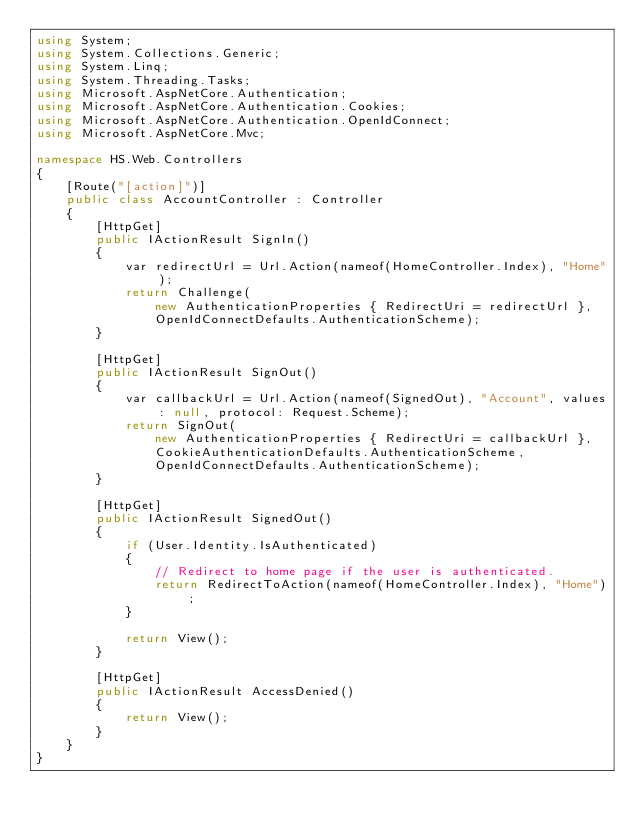Convert code to text. <code><loc_0><loc_0><loc_500><loc_500><_C#_>using System;
using System.Collections.Generic;
using System.Linq;
using System.Threading.Tasks;
using Microsoft.AspNetCore.Authentication;
using Microsoft.AspNetCore.Authentication.Cookies;
using Microsoft.AspNetCore.Authentication.OpenIdConnect;
using Microsoft.AspNetCore.Mvc;

namespace HS.Web.Controllers
{
    [Route("[action]")]
    public class AccountController : Controller
    {
        [HttpGet]
        public IActionResult SignIn()
        {
            var redirectUrl = Url.Action(nameof(HomeController.Index), "Home");
            return Challenge(
                new AuthenticationProperties { RedirectUri = redirectUrl },
                OpenIdConnectDefaults.AuthenticationScheme);
        }

        [HttpGet]
        public IActionResult SignOut()
        {
            var callbackUrl = Url.Action(nameof(SignedOut), "Account", values: null, protocol: Request.Scheme);
            return SignOut(
                new AuthenticationProperties { RedirectUri = callbackUrl },
                CookieAuthenticationDefaults.AuthenticationScheme,
                OpenIdConnectDefaults.AuthenticationScheme);
        }

        [HttpGet]
        public IActionResult SignedOut()
        {
            if (User.Identity.IsAuthenticated)
            {
                // Redirect to home page if the user is authenticated.
                return RedirectToAction(nameof(HomeController.Index), "Home");
            }

            return View();
        }

        [HttpGet]
        public IActionResult AccessDenied()
        {
            return View();
        }
    }
}
</code> 